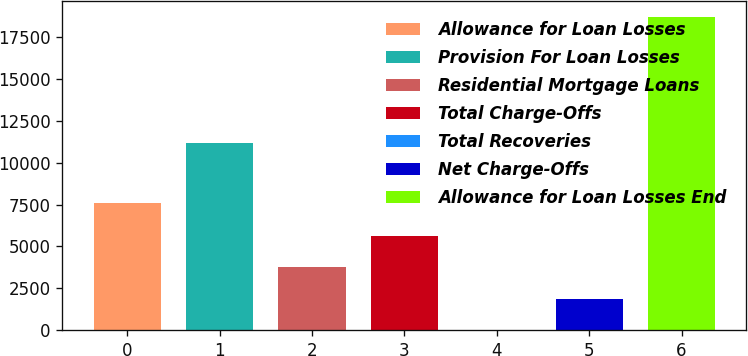Convert chart to OTSL. <chart><loc_0><loc_0><loc_500><loc_500><bar_chart><fcel>Allowance for Loan Losses<fcel>Provision For Loan Losses<fcel>Residential Mortgage Loans<fcel>Total Charge-Offs<fcel>Total Recoveries<fcel>Net Charge-Offs<fcel>Allowance for Loan Losses End<nl><fcel>7593<fcel>11153<fcel>3746<fcel>5614.5<fcel>9<fcel>1877.5<fcel>18694<nl></chart> 